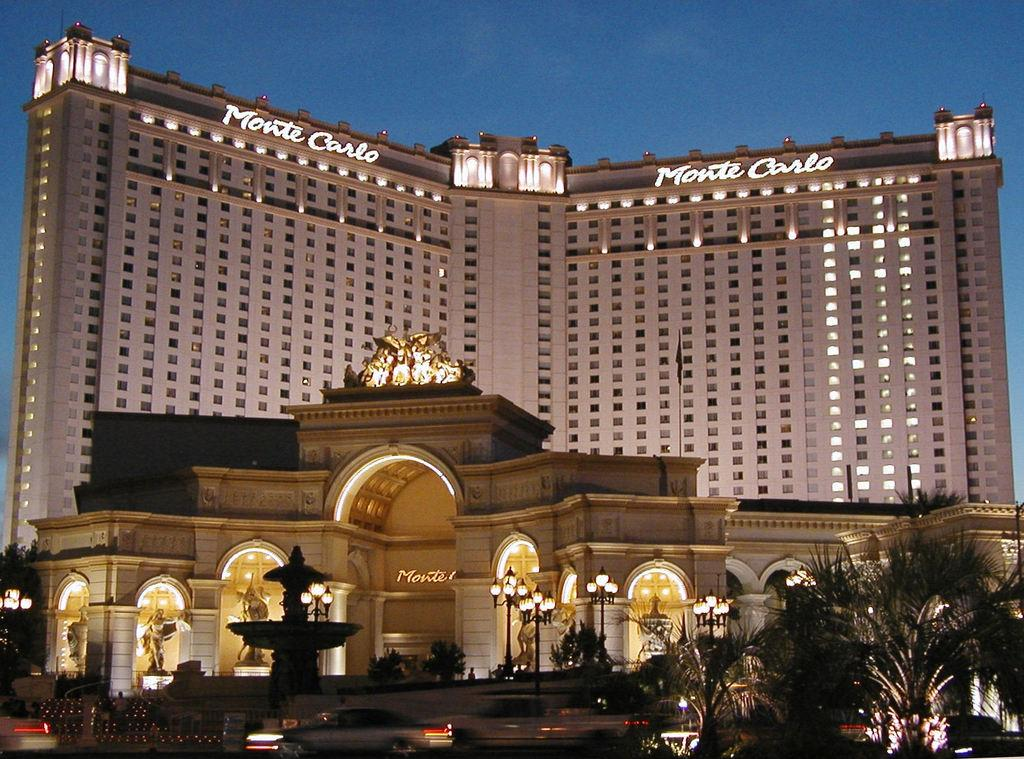What type of natural elements can be seen in the image? There are trees in the image. What artificial elements can be seen in the image? There are lights, vehicles, a fountain, and a huge building in the image. What architectural feature is present in front of the building? There are statues in front of the building. What is visible in the background of the image? The sky is visible in the background of the image. How many eggs are present in the image? There are no eggs present in the image. What type of guide is standing next to the statues in the image? There is no guide present in the image; only statues are mentioned in front of the building. 